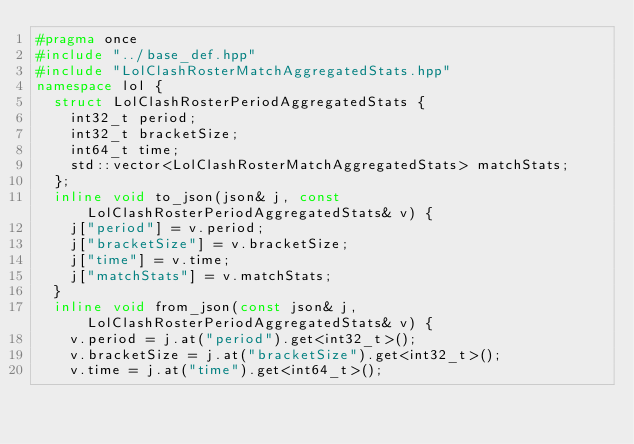Convert code to text. <code><loc_0><loc_0><loc_500><loc_500><_C++_>#pragma once
#include "../base_def.hpp" 
#include "LolClashRosterMatchAggregatedStats.hpp"
namespace lol {
  struct LolClashRosterPeriodAggregatedStats { 
    int32_t period;
    int32_t bracketSize;
    int64_t time;
    std::vector<LolClashRosterMatchAggregatedStats> matchStats; 
  };
  inline void to_json(json& j, const LolClashRosterPeriodAggregatedStats& v) {
    j["period"] = v.period; 
    j["bracketSize"] = v.bracketSize; 
    j["time"] = v.time; 
    j["matchStats"] = v.matchStats; 
  }
  inline void from_json(const json& j, LolClashRosterPeriodAggregatedStats& v) {
    v.period = j.at("period").get<int32_t>(); 
    v.bracketSize = j.at("bracketSize").get<int32_t>(); 
    v.time = j.at("time").get<int64_t>(); </code> 